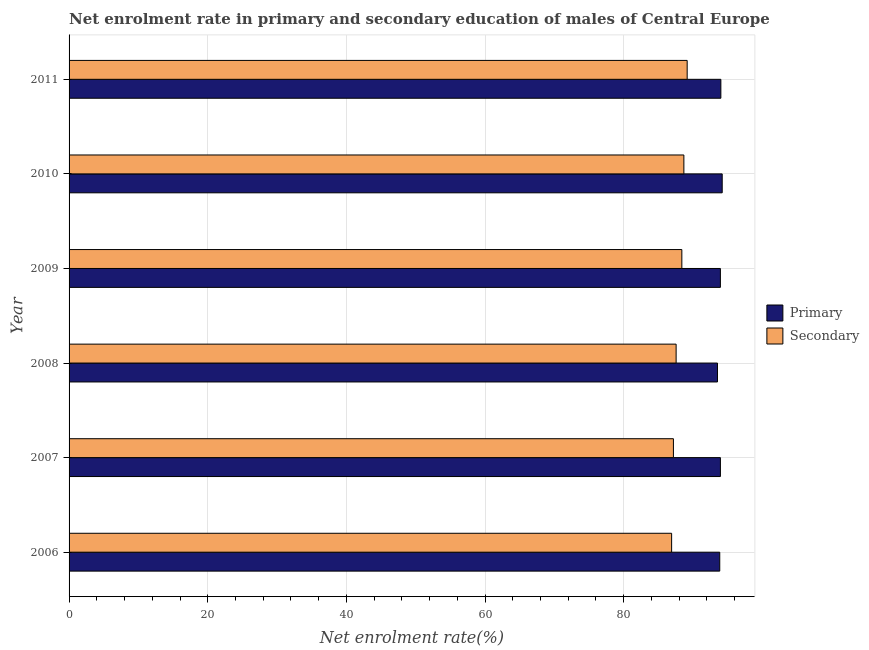How many different coloured bars are there?
Offer a very short reply. 2. What is the label of the 3rd group of bars from the top?
Ensure brevity in your answer.  2009. In how many cases, is the number of bars for a given year not equal to the number of legend labels?
Give a very brief answer. 0. What is the enrollment rate in secondary education in 2008?
Keep it short and to the point. 87.56. Across all years, what is the maximum enrollment rate in primary education?
Provide a succinct answer. 94.21. Across all years, what is the minimum enrollment rate in primary education?
Offer a terse response. 93.53. In which year was the enrollment rate in primary education maximum?
Your response must be concise. 2010. In which year was the enrollment rate in secondary education minimum?
Offer a terse response. 2006. What is the total enrollment rate in secondary education in the graph?
Provide a succinct answer. 527.87. What is the difference between the enrollment rate in primary education in 2008 and that in 2009?
Ensure brevity in your answer.  -0.42. What is the difference between the enrollment rate in primary education in 2009 and the enrollment rate in secondary education in 2008?
Your answer should be very brief. 6.38. What is the average enrollment rate in primary education per year?
Make the answer very short. 93.92. In the year 2009, what is the difference between the enrollment rate in secondary education and enrollment rate in primary education?
Make the answer very short. -5.56. Is the enrollment rate in primary education in 2010 less than that in 2011?
Make the answer very short. No. Is the difference between the enrollment rate in secondary education in 2009 and 2011 greater than the difference between the enrollment rate in primary education in 2009 and 2011?
Ensure brevity in your answer.  No. What is the difference between the highest and the second highest enrollment rate in secondary education?
Provide a succinct answer. 0.48. What is the difference between the highest and the lowest enrollment rate in secondary education?
Give a very brief answer. 2.24. In how many years, is the enrollment rate in primary education greater than the average enrollment rate in primary education taken over all years?
Give a very brief answer. 4. Is the sum of the enrollment rate in primary education in 2006 and 2008 greater than the maximum enrollment rate in secondary education across all years?
Your answer should be very brief. Yes. What does the 2nd bar from the top in 2010 represents?
Keep it short and to the point. Primary. What does the 2nd bar from the bottom in 2010 represents?
Give a very brief answer. Secondary. Are all the bars in the graph horizontal?
Your answer should be compact. Yes. What is the difference between two consecutive major ticks on the X-axis?
Provide a short and direct response. 20. Does the graph contain grids?
Your answer should be compact. Yes. Where does the legend appear in the graph?
Make the answer very short. Center right. How are the legend labels stacked?
Your answer should be compact. Vertical. What is the title of the graph?
Keep it short and to the point. Net enrolment rate in primary and secondary education of males of Central Europe. Does "Urban agglomerations" appear as one of the legend labels in the graph?
Your answer should be compact. No. What is the label or title of the X-axis?
Offer a terse response. Net enrolment rate(%). What is the label or title of the Y-axis?
Keep it short and to the point. Year. What is the Net enrolment rate(%) in Primary in 2006?
Your response must be concise. 93.85. What is the Net enrolment rate(%) in Secondary in 2006?
Ensure brevity in your answer.  86.91. What is the Net enrolment rate(%) in Primary in 2007?
Your answer should be compact. 93.95. What is the Net enrolment rate(%) of Secondary in 2007?
Keep it short and to the point. 87.17. What is the Net enrolment rate(%) in Primary in 2008?
Give a very brief answer. 93.53. What is the Net enrolment rate(%) in Secondary in 2008?
Your response must be concise. 87.56. What is the Net enrolment rate(%) of Primary in 2009?
Ensure brevity in your answer.  93.95. What is the Net enrolment rate(%) in Secondary in 2009?
Keep it short and to the point. 88.39. What is the Net enrolment rate(%) of Primary in 2010?
Make the answer very short. 94.21. What is the Net enrolment rate(%) of Secondary in 2010?
Your answer should be very brief. 88.68. What is the Net enrolment rate(%) of Primary in 2011?
Keep it short and to the point. 94.01. What is the Net enrolment rate(%) of Secondary in 2011?
Offer a terse response. 89.16. Across all years, what is the maximum Net enrolment rate(%) in Primary?
Offer a terse response. 94.21. Across all years, what is the maximum Net enrolment rate(%) in Secondary?
Offer a terse response. 89.16. Across all years, what is the minimum Net enrolment rate(%) of Primary?
Your response must be concise. 93.53. Across all years, what is the minimum Net enrolment rate(%) in Secondary?
Provide a succinct answer. 86.91. What is the total Net enrolment rate(%) in Primary in the graph?
Offer a very short reply. 563.5. What is the total Net enrolment rate(%) in Secondary in the graph?
Your answer should be very brief. 527.87. What is the difference between the Net enrolment rate(%) in Primary in 2006 and that in 2007?
Give a very brief answer. -0.09. What is the difference between the Net enrolment rate(%) in Secondary in 2006 and that in 2007?
Keep it short and to the point. -0.26. What is the difference between the Net enrolment rate(%) in Primary in 2006 and that in 2008?
Provide a succinct answer. 0.33. What is the difference between the Net enrolment rate(%) in Secondary in 2006 and that in 2008?
Your answer should be very brief. -0.65. What is the difference between the Net enrolment rate(%) in Primary in 2006 and that in 2009?
Ensure brevity in your answer.  -0.09. What is the difference between the Net enrolment rate(%) of Secondary in 2006 and that in 2009?
Give a very brief answer. -1.47. What is the difference between the Net enrolment rate(%) in Primary in 2006 and that in 2010?
Your answer should be compact. -0.36. What is the difference between the Net enrolment rate(%) in Secondary in 2006 and that in 2010?
Make the answer very short. -1.77. What is the difference between the Net enrolment rate(%) in Primary in 2006 and that in 2011?
Your response must be concise. -0.16. What is the difference between the Net enrolment rate(%) of Secondary in 2006 and that in 2011?
Give a very brief answer. -2.24. What is the difference between the Net enrolment rate(%) of Primary in 2007 and that in 2008?
Offer a terse response. 0.42. What is the difference between the Net enrolment rate(%) of Secondary in 2007 and that in 2008?
Provide a succinct answer. -0.39. What is the difference between the Net enrolment rate(%) of Primary in 2007 and that in 2009?
Your response must be concise. 0. What is the difference between the Net enrolment rate(%) of Secondary in 2007 and that in 2009?
Offer a terse response. -1.21. What is the difference between the Net enrolment rate(%) in Primary in 2007 and that in 2010?
Offer a very short reply. -0.26. What is the difference between the Net enrolment rate(%) in Secondary in 2007 and that in 2010?
Offer a very short reply. -1.51. What is the difference between the Net enrolment rate(%) in Primary in 2007 and that in 2011?
Your response must be concise. -0.07. What is the difference between the Net enrolment rate(%) in Secondary in 2007 and that in 2011?
Give a very brief answer. -1.98. What is the difference between the Net enrolment rate(%) in Primary in 2008 and that in 2009?
Provide a short and direct response. -0.42. What is the difference between the Net enrolment rate(%) of Secondary in 2008 and that in 2009?
Provide a succinct answer. -0.82. What is the difference between the Net enrolment rate(%) of Primary in 2008 and that in 2010?
Provide a short and direct response. -0.68. What is the difference between the Net enrolment rate(%) in Secondary in 2008 and that in 2010?
Your answer should be very brief. -1.12. What is the difference between the Net enrolment rate(%) of Primary in 2008 and that in 2011?
Your answer should be very brief. -0.49. What is the difference between the Net enrolment rate(%) in Secondary in 2008 and that in 2011?
Keep it short and to the point. -1.59. What is the difference between the Net enrolment rate(%) of Primary in 2009 and that in 2010?
Your answer should be very brief. -0.26. What is the difference between the Net enrolment rate(%) in Secondary in 2009 and that in 2010?
Your answer should be compact. -0.29. What is the difference between the Net enrolment rate(%) of Primary in 2009 and that in 2011?
Keep it short and to the point. -0.07. What is the difference between the Net enrolment rate(%) in Secondary in 2009 and that in 2011?
Ensure brevity in your answer.  -0.77. What is the difference between the Net enrolment rate(%) of Primary in 2010 and that in 2011?
Provide a succinct answer. 0.19. What is the difference between the Net enrolment rate(%) in Secondary in 2010 and that in 2011?
Offer a terse response. -0.48. What is the difference between the Net enrolment rate(%) in Primary in 2006 and the Net enrolment rate(%) in Secondary in 2007?
Ensure brevity in your answer.  6.68. What is the difference between the Net enrolment rate(%) in Primary in 2006 and the Net enrolment rate(%) in Secondary in 2008?
Your answer should be compact. 6.29. What is the difference between the Net enrolment rate(%) of Primary in 2006 and the Net enrolment rate(%) of Secondary in 2009?
Give a very brief answer. 5.47. What is the difference between the Net enrolment rate(%) in Primary in 2006 and the Net enrolment rate(%) in Secondary in 2010?
Provide a short and direct response. 5.17. What is the difference between the Net enrolment rate(%) in Primary in 2006 and the Net enrolment rate(%) in Secondary in 2011?
Give a very brief answer. 4.7. What is the difference between the Net enrolment rate(%) in Primary in 2007 and the Net enrolment rate(%) in Secondary in 2008?
Provide a succinct answer. 6.39. What is the difference between the Net enrolment rate(%) of Primary in 2007 and the Net enrolment rate(%) of Secondary in 2009?
Your answer should be very brief. 5.56. What is the difference between the Net enrolment rate(%) of Primary in 2007 and the Net enrolment rate(%) of Secondary in 2010?
Your response must be concise. 5.27. What is the difference between the Net enrolment rate(%) in Primary in 2007 and the Net enrolment rate(%) in Secondary in 2011?
Make the answer very short. 4.79. What is the difference between the Net enrolment rate(%) in Primary in 2008 and the Net enrolment rate(%) in Secondary in 2009?
Your response must be concise. 5.14. What is the difference between the Net enrolment rate(%) in Primary in 2008 and the Net enrolment rate(%) in Secondary in 2010?
Give a very brief answer. 4.85. What is the difference between the Net enrolment rate(%) of Primary in 2008 and the Net enrolment rate(%) of Secondary in 2011?
Make the answer very short. 4.37. What is the difference between the Net enrolment rate(%) in Primary in 2009 and the Net enrolment rate(%) in Secondary in 2010?
Ensure brevity in your answer.  5.27. What is the difference between the Net enrolment rate(%) in Primary in 2009 and the Net enrolment rate(%) in Secondary in 2011?
Your response must be concise. 4.79. What is the difference between the Net enrolment rate(%) in Primary in 2010 and the Net enrolment rate(%) in Secondary in 2011?
Make the answer very short. 5.05. What is the average Net enrolment rate(%) in Primary per year?
Provide a succinct answer. 93.92. What is the average Net enrolment rate(%) of Secondary per year?
Provide a short and direct response. 87.98. In the year 2006, what is the difference between the Net enrolment rate(%) in Primary and Net enrolment rate(%) in Secondary?
Ensure brevity in your answer.  6.94. In the year 2007, what is the difference between the Net enrolment rate(%) of Primary and Net enrolment rate(%) of Secondary?
Keep it short and to the point. 6.78. In the year 2008, what is the difference between the Net enrolment rate(%) in Primary and Net enrolment rate(%) in Secondary?
Make the answer very short. 5.97. In the year 2009, what is the difference between the Net enrolment rate(%) in Primary and Net enrolment rate(%) in Secondary?
Your answer should be very brief. 5.56. In the year 2010, what is the difference between the Net enrolment rate(%) of Primary and Net enrolment rate(%) of Secondary?
Give a very brief answer. 5.53. In the year 2011, what is the difference between the Net enrolment rate(%) in Primary and Net enrolment rate(%) in Secondary?
Offer a very short reply. 4.86. What is the ratio of the Net enrolment rate(%) of Secondary in 2006 to that in 2007?
Your answer should be compact. 1. What is the ratio of the Net enrolment rate(%) of Primary in 2006 to that in 2009?
Offer a very short reply. 1. What is the ratio of the Net enrolment rate(%) in Secondary in 2006 to that in 2009?
Your answer should be very brief. 0.98. What is the ratio of the Net enrolment rate(%) in Secondary in 2006 to that in 2010?
Your answer should be very brief. 0.98. What is the ratio of the Net enrolment rate(%) in Secondary in 2006 to that in 2011?
Your answer should be compact. 0.97. What is the ratio of the Net enrolment rate(%) in Secondary in 2007 to that in 2008?
Your answer should be compact. 1. What is the ratio of the Net enrolment rate(%) in Secondary in 2007 to that in 2009?
Your answer should be very brief. 0.99. What is the ratio of the Net enrolment rate(%) of Primary in 2007 to that in 2010?
Make the answer very short. 1. What is the ratio of the Net enrolment rate(%) in Secondary in 2007 to that in 2010?
Your answer should be very brief. 0.98. What is the ratio of the Net enrolment rate(%) in Secondary in 2007 to that in 2011?
Give a very brief answer. 0.98. What is the ratio of the Net enrolment rate(%) of Secondary in 2008 to that in 2009?
Your response must be concise. 0.99. What is the ratio of the Net enrolment rate(%) in Secondary in 2008 to that in 2010?
Provide a succinct answer. 0.99. What is the ratio of the Net enrolment rate(%) of Secondary in 2008 to that in 2011?
Offer a terse response. 0.98. What is the ratio of the Net enrolment rate(%) of Secondary in 2009 to that in 2010?
Give a very brief answer. 1. What is the ratio of the Net enrolment rate(%) in Primary in 2009 to that in 2011?
Ensure brevity in your answer.  1. What is the ratio of the Net enrolment rate(%) of Primary in 2010 to that in 2011?
Your response must be concise. 1. What is the difference between the highest and the second highest Net enrolment rate(%) of Primary?
Offer a terse response. 0.19. What is the difference between the highest and the second highest Net enrolment rate(%) of Secondary?
Make the answer very short. 0.48. What is the difference between the highest and the lowest Net enrolment rate(%) in Primary?
Offer a very short reply. 0.68. What is the difference between the highest and the lowest Net enrolment rate(%) in Secondary?
Keep it short and to the point. 2.24. 